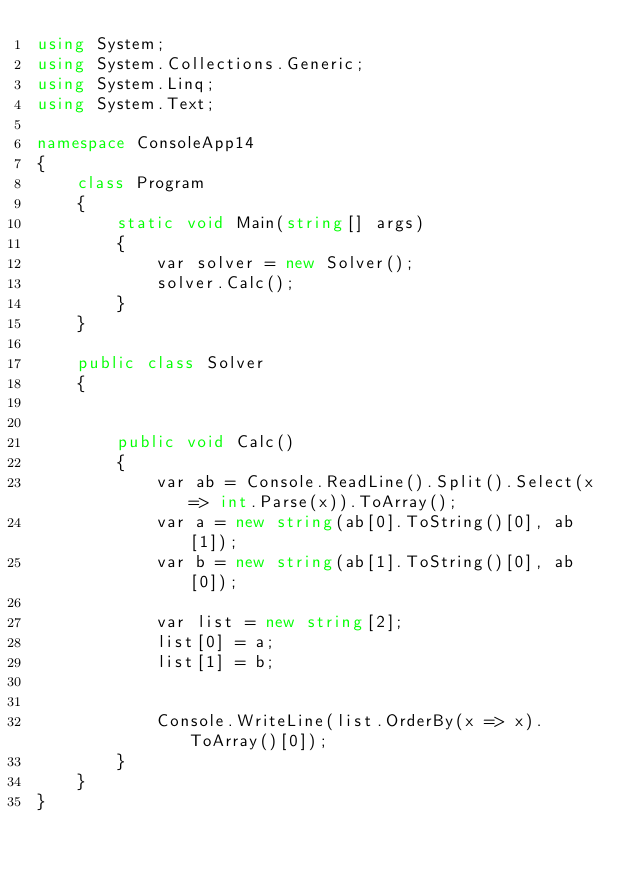Convert code to text. <code><loc_0><loc_0><loc_500><loc_500><_C#_>using System;
using System.Collections.Generic;
using System.Linq;
using System.Text;

namespace ConsoleApp14
{
    class Program
    {
        static void Main(string[] args)
        {
            var solver = new Solver();
            solver.Calc();
        }
    }

    public class Solver
    {


        public void Calc()
        {
            var ab = Console.ReadLine().Split().Select(x => int.Parse(x)).ToArray();
            var a = new string(ab[0].ToString()[0], ab[1]);
            var b = new string(ab[1].ToString()[0], ab[0]);

            var list = new string[2];
            list[0] = a;
            list[1] = b;


            Console.WriteLine(list.OrderBy(x => x).ToArray()[0]);
        }
    }
}</code> 